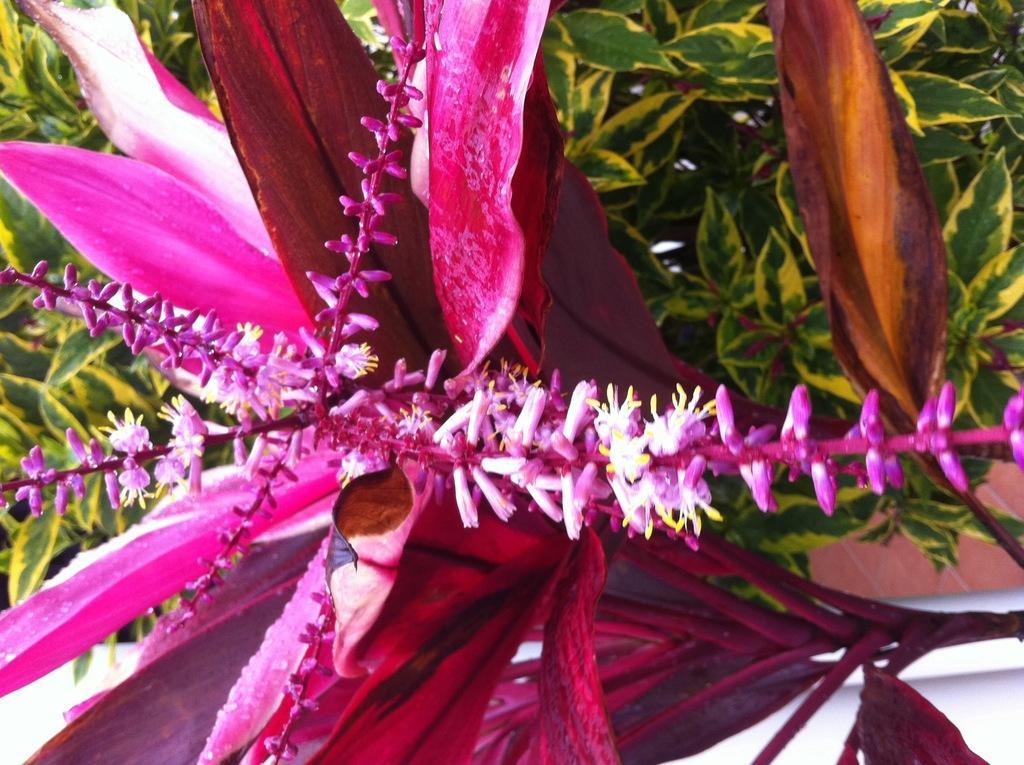In one or two sentences, can you explain what this image depicts? In the foreground of this image, there is a pink color flower to the plant and in the background, there are plants. 